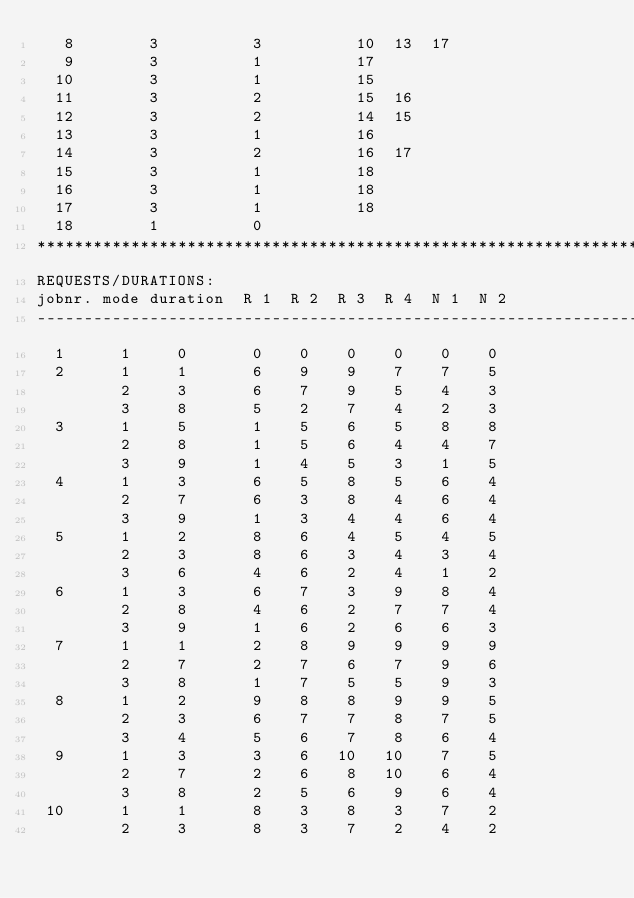<code> <loc_0><loc_0><loc_500><loc_500><_ObjectiveC_>   8        3          3          10  13  17
   9        3          1          17
  10        3          1          15
  11        3          2          15  16
  12        3          2          14  15
  13        3          1          16
  14        3          2          16  17
  15        3          1          18
  16        3          1          18
  17        3          1          18
  18        1          0        
************************************************************************
REQUESTS/DURATIONS:
jobnr. mode duration  R 1  R 2  R 3  R 4  N 1  N 2
------------------------------------------------------------------------
  1      1     0       0    0    0    0    0    0
  2      1     1       6    9    9    7    7    5
         2     3       6    7    9    5    4    3
         3     8       5    2    7    4    2    3
  3      1     5       1    5    6    5    8    8
         2     8       1    5    6    4    4    7
         3     9       1    4    5    3    1    5
  4      1     3       6    5    8    5    6    4
         2     7       6    3    8    4    6    4
         3     9       1    3    4    4    6    4
  5      1     2       8    6    4    5    4    5
         2     3       8    6    3    4    3    4
         3     6       4    6    2    4    1    2
  6      1     3       6    7    3    9    8    4
         2     8       4    6    2    7    7    4
         3     9       1    6    2    6    6    3
  7      1     1       2    8    9    9    9    9
         2     7       2    7    6    7    9    6
         3     8       1    7    5    5    9    3
  8      1     2       9    8    8    9    9    5
         2     3       6    7    7    8    7    5
         3     4       5    6    7    8    6    4
  9      1     3       3    6   10   10    7    5
         2     7       2    6    8   10    6    4
         3     8       2    5    6    9    6    4
 10      1     1       8    3    8    3    7    2
         2     3       8    3    7    2    4    2</code> 